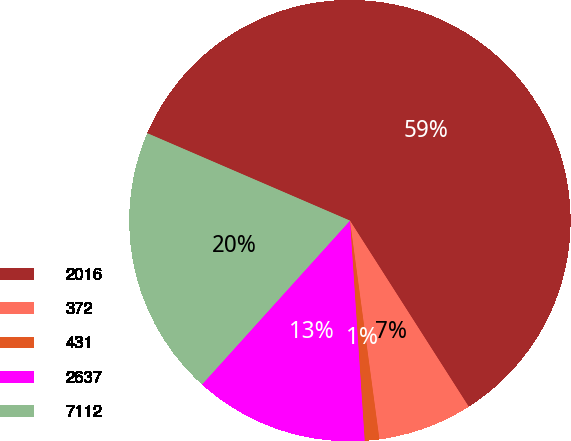Convert chart to OTSL. <chart><loc_0><loc_0><loc_500><loc_500><pie_chart><fcel>2016<fcel>372<fcel>431<fcel>2637<fcel>7112<nl><fcel>59.47%<fcel>6.91%<fcel>1.07%<fcel>12.75%<fcel>19.79%<nl></chart> 